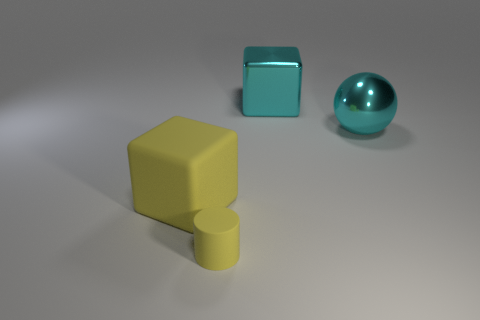What color is the object in front of the yellow object that is behind the yellow object to the right of the yellow block?
Your answer should be compact. Yellow. Is the size of the shiny ball the same as the matte block?
Provide a succinct answer. Yes. Is there any other thing that is the same shape as the large yellow matte object?
Keep it short and to the point. Yes. What number of things are large cyan objects that are in front of the cyan block or large blue objects?
Offer a terse response. 1. Is the large yellow thing the same shape as the small object?
Provide a short and direct response. No. What number of other objects are the same size as the yellow matte cube?
Ensure brevity in your answer.  2. What color is the big metallic ball?
Your answer should be very brief. Cyan. What number of tiny objects are brown matte things or cyan metallic balls?
Make the answer very short. 0. Is the size of the thing that is on the right side of the large shiny cube the same as the cube on the right side of the large yellow cube?
Provide a succinct answer. Yes. What size is the cyan object that is the same shape as the big yellow thing?
Your answer should be very brief. Large. 